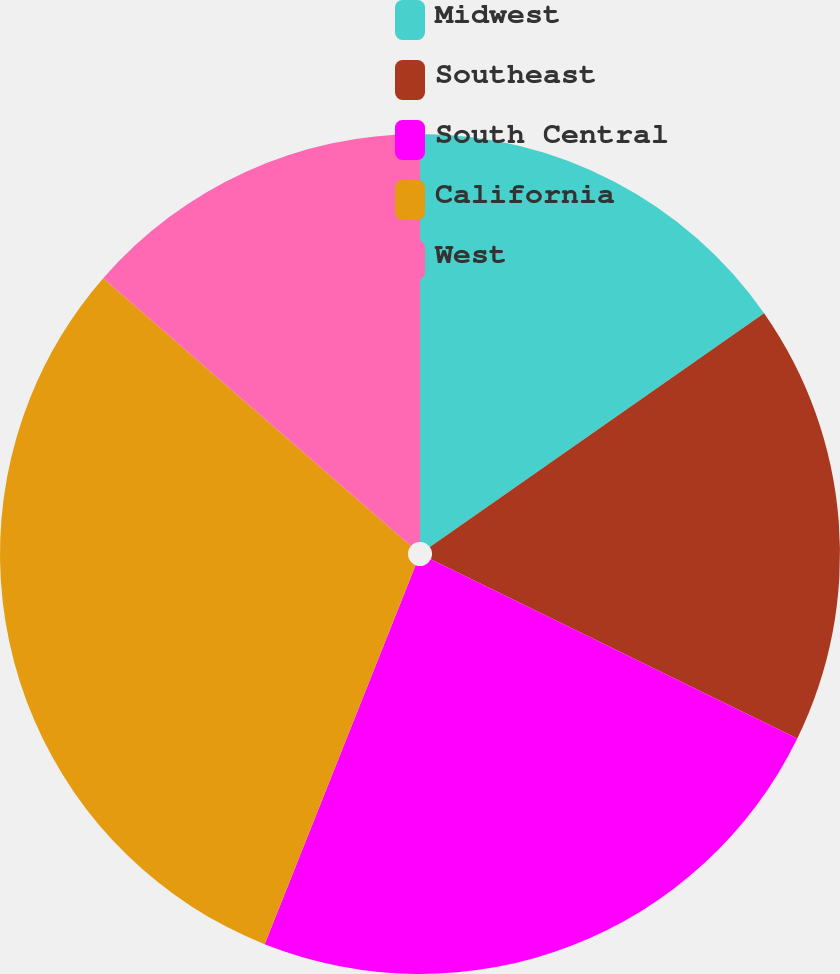<chart> <loc_0><loc_0><loc_500><loc_500><pie_chart><fcel>Midwest<fcel>Southeast<fcel>South Central<fcel>California<fcel>West<nl><fcel>15.28%<fcel>16.96%<fcel>23.79%<fcel>30.37%<fcel>13.6%<nl></chart> 